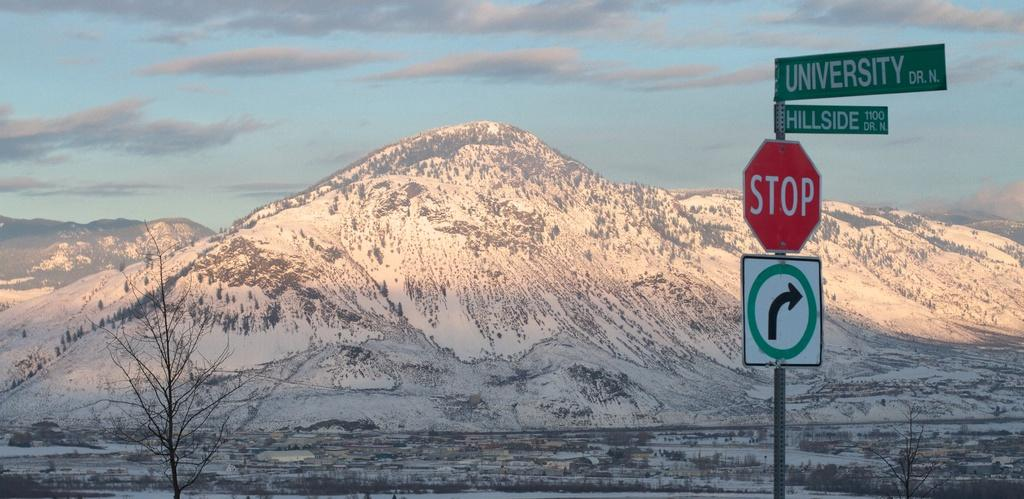<image>
Relay a brief, clear account of the picture shown. A stop sign is shown at the corner of University Dr. and Hillside Dr., with snow covered mountains in the background. 